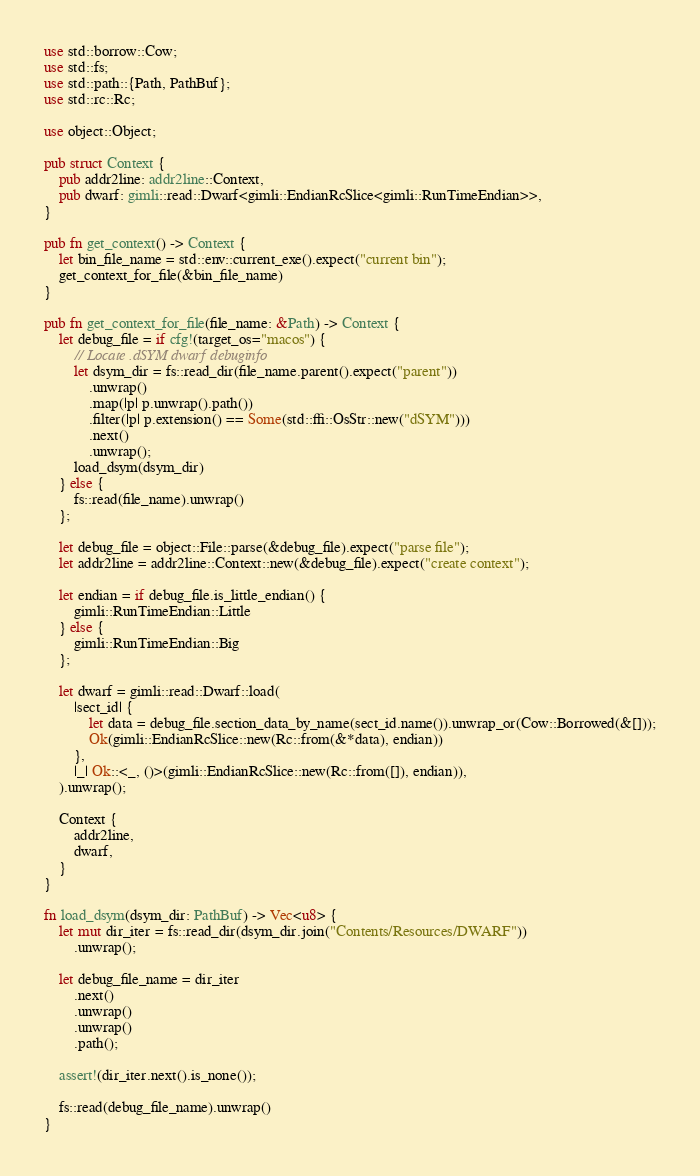Convert code to text. <code><loc_0><loc_0><loc_500><loc_500><_Rust_>use std::borrow::Cow;
use std::fs;
use std::path::{Path, PathBuf};
use std::rc::Rc;

use object::Object;

pub struct Context {
    pub addr2line: addr2line::Context,
    pub dwarf: gimli::read::Dwarf<gimli::EndianRcSlice<gimli::RunTimeEndian>>,
}

pub fn get_context() -> Context {
    let bin_file_name = std::env::current_exe().expect("current bin");
    get_context_for_file(&bin_file_name)
}

pub fn get_context_for_file(file_name: &Path) -> Context {
    let debug_file = if cfg!(target_os="macos") {
        // Locate .dSYM dwarf debuginfo
        let dsym_dir = fs::read_dir(file_name.parent().expect("parent"))
            .unwrap()
            .map(|p| p.unwrap().path())
            .filter(|p| p.extension() == Some(std::ffi::OsStr::new("dSYM")))
            .next()
            .unwrap();
        load_dsym(dsym_dir)
    } else {
        fs::read(file_name).unwrap()
    };

    let debug_file = object::File::parse(&debug_file).expect("parse file");
    let addr2line = addr2line::Context::new(&debug_file).expect("create context");

    let endian = if debug_file.is_little_endian() {
        gimli::RunTimeEndian::Little
    } else {
        gimli::RunTimeEndian::Big
    };

    let dwarf = gimli::read::Dwarf::load(
        |sect_id| {
            let data = debug_file.section_data_by_name(sect_id.name()).unwrap_or(Cow::Borrowed(&[]));
            Ok(gimli::EndianRcSlice::new(Rc::from(&*data), endian))
        },
        |_| Ok::<_, ()>(gimli::EndianRcSlice::new(Rc::from([]), endian)),
    ).unwrap();

    Context {
        addr2line,
        dwarf,
    }
}

fn load_dsym(dsym_dir: PathBuf) -> Vec<u8> {
    let mut dir_iter = fs::read_dir(dsym_dir.join("Contents/Resources/DWARF"))
        .unwrap();

    let debug_file_name = dir_iter
        .next()
        .unwrap()
        .unwrap()
        .path();

    assert!(dir_iter.next().is_none());

    fs::read(debug_file_name).unwrap()
}
</code> 